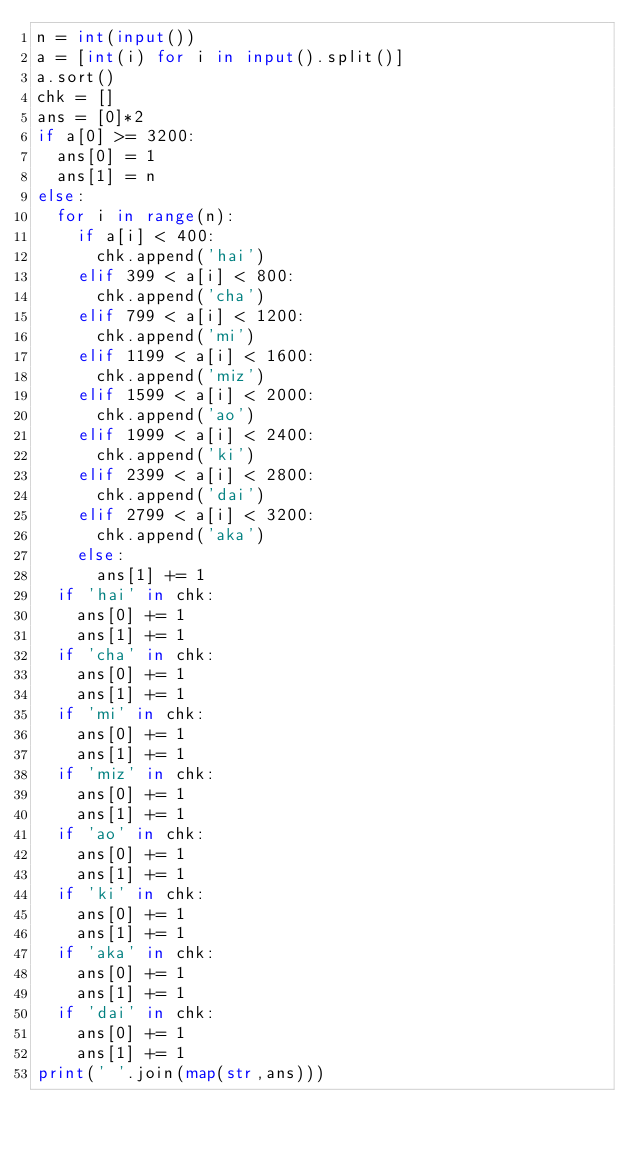Convert code to text. <code><loc_0><loc_0><loc_500><loc_500><_Python_>n = int(input())
a = [int(i) for i in input().split()]
a.sort()
chk = []
ans = [0]*2
if a[0] >= 3200:
  ans[0] = 1
  ans[1] = n
else:
  for i in range(n):
    if a[i] < 400:
      chk.append('hai')
    elif 399 < a[i] < 800:
      chk.append('cha')
    elif 799 < a[i] < 1200:
      chk.append('mi')
    elif 1199 < a[i] < 1600:
      chk.append('miz')
    elif 1599 < a[i] < 2000:
      chk.append('ao')
    elif 1999 < a[i] < 2400:
      chk.append('ki')
    elif 2399 < a[i] < 2800:
      chk.append('dai')
    elif 2799 < a[i] < 3200:
      chk.append('aka')
    else:
      ans[1] += 1
  if 'hai' in chk:
    ans[0] += 1
    ans[1] += 1
  if 'cha' in chk:
    ans[0] += 1
    ans[1] += 1
  if 'mi' in chk:
    ans[0] += 1
    ans[1] += 1
  if 'miz' in chk:
    ans[0] += 1
    ans[1] += 1
  if 'ao' in chk:
    ans[0] += 1
    ans[1] += 1
  if 'ki' in chk:
    ans[0] += 1
    ans[1] += 1
  if 'aka' in chk:
    ans[0] += 1
    ans[1] += 1
  if 'dai' in chk:
    ans[0] += 1
    ans[1] += 1
print(' '.join(map(str,ans)))</code> 